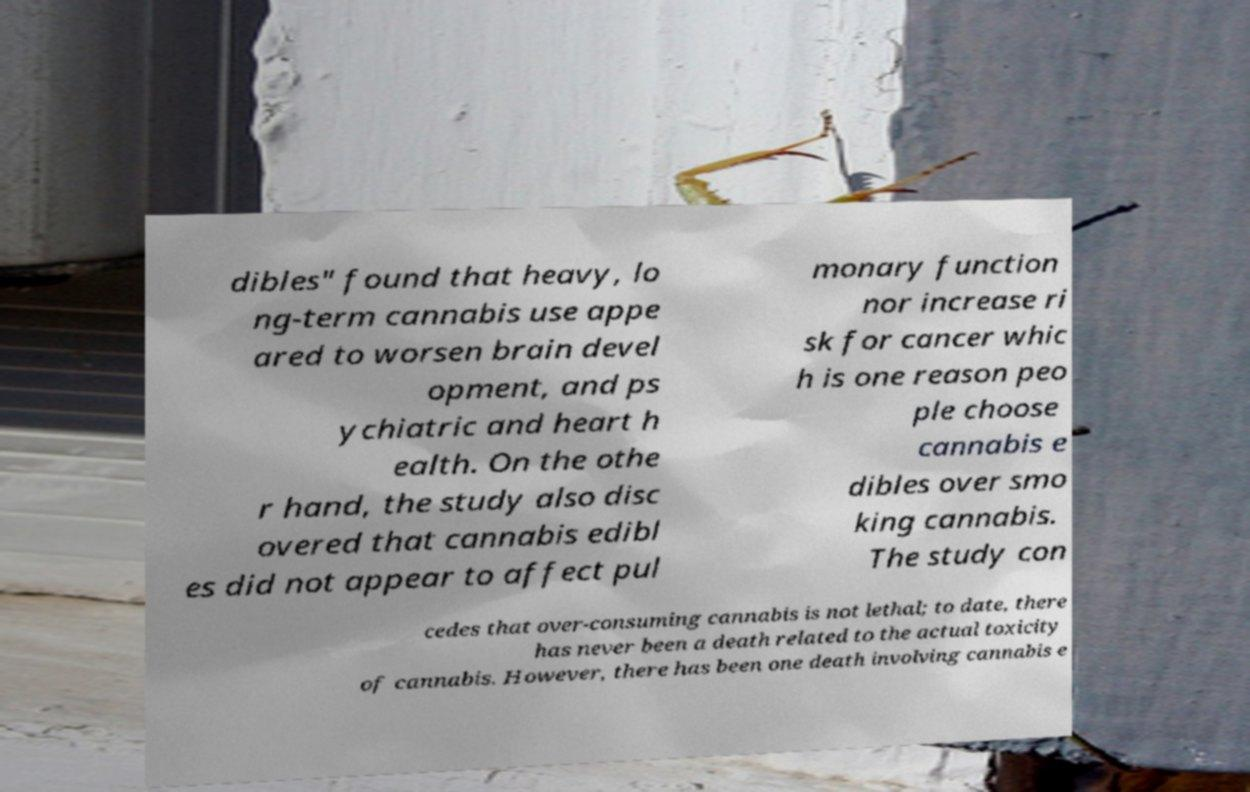Could you extract and type out the text from this image? dibles" found that heavy, lo ng-term cannabis use appe ared to worsen brain devel opment, and ps ychiatric and heart h ealth. On the othe r hand, the study also disc overed that cannabis edibl es did not appear to affect pul monary function nor increase ri sk for cancer whic h is one reason peo ple choose cannabis e dibles over smo king cannabis. The study con cedes that over-consuming cannabis is not lethal; to date, there has never been a death related to the actual toxicity of cannabis. However, there has been one death involving cannabis e 